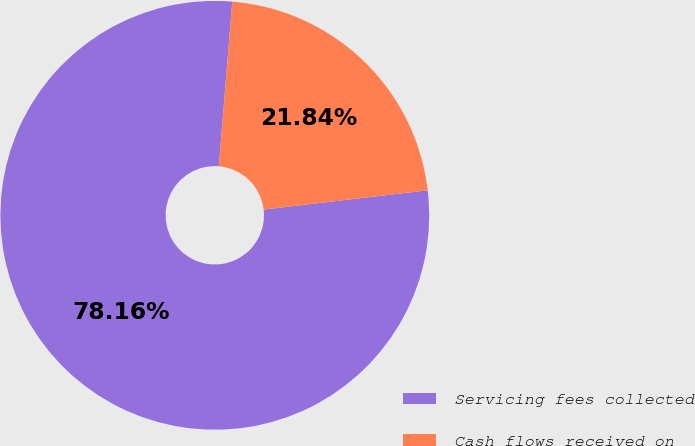<chart> <loc_0><loc_0><loc_500><loc_500><pie_chart><fcel>Servicing fees collected<fcel>Cash flows received on<nl><fcel>78.16%<fcel>21.84%<nl></chart> 